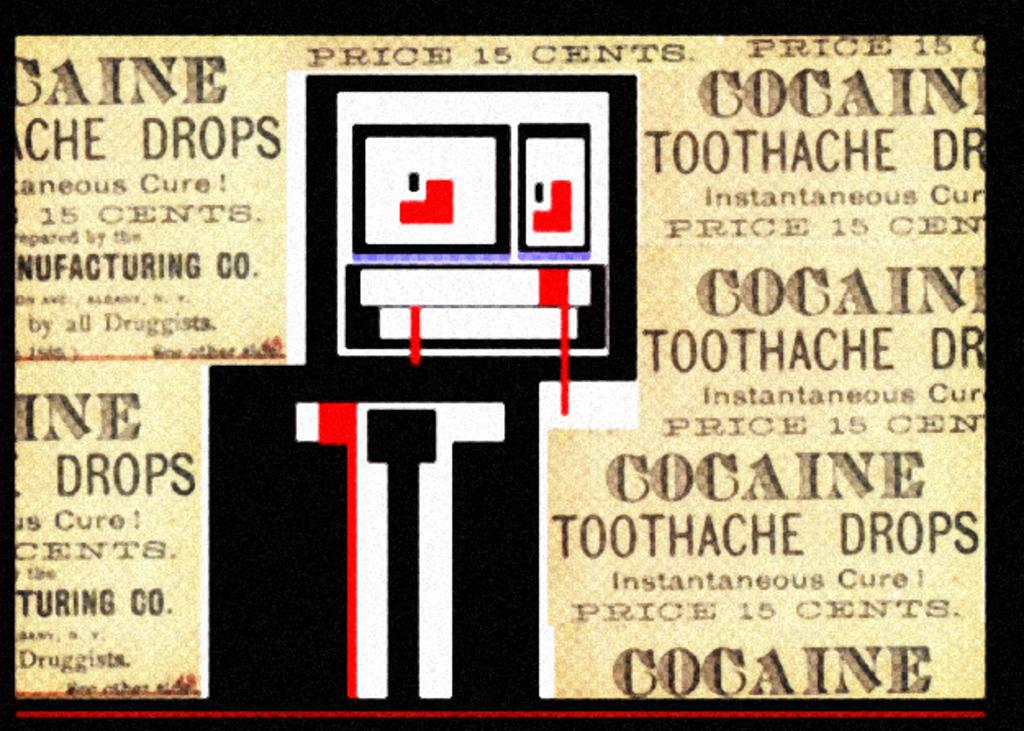<image>
Give a short and clear explanation of the subsequent image. a sign that has the word cocaine on it 